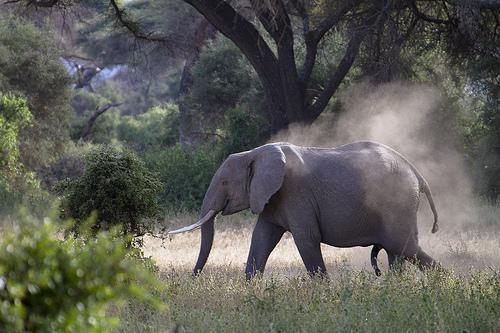How many animals is there?
Give a very brief answer. 1. 